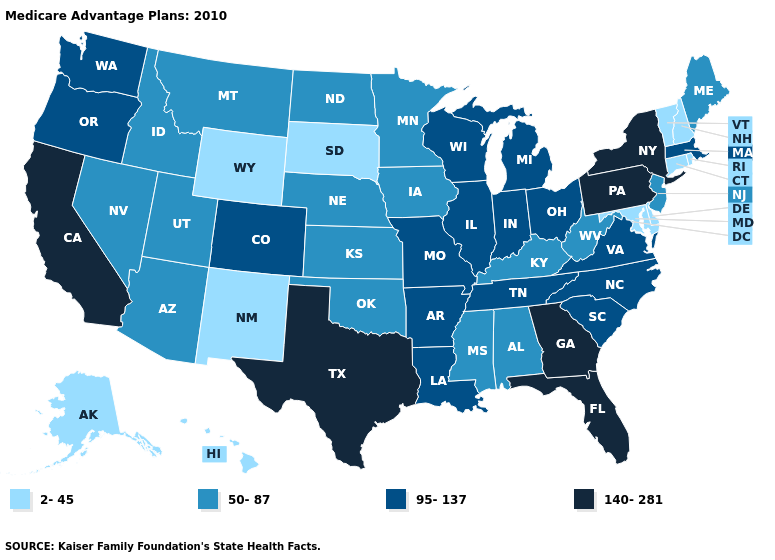Name the states that have a value in the range 95-137?
Keep it brief. Arkansas, Colorado, Illinois, Indiana, Louisiana, Massachusetts, Michigan, Missouri, North Carolina, Ohio, Oregon, South Carolina, Tennessee, Virginia, Washington, Wisconsin. Does Kentucky have the lowest value in the South?
Keep it brief. No. Name the states that have a value in the range 50-87?
Short answer required. Alabama, Arizona, Iowa, Idaho, Kansas, Kentucky, Maine, Minnesota, Mississippi, Montana, North Dakota, Nebraska, New Jersey, Nevada, Oklahoma, Utah, West Virginia. Which states hav the highest value in the West?
Give a very brief answer. California. What is the highest value in the Northeast ?
Answer briefly. 140-281. Name the states that have a value in the range 95-137?
Short answer required. Arkansas, Colorado, Illinois, Indiana, Louisiana, Massachusetts, Michigan, Missouri, North Carolina, Ohio, Oregon, South Carolina, Tennessee, Virginia, Washington, Wisconsin. Does Wyoming have the highest value in the USA?
Concise answer only. No. What is the value of Michigan?
Short answer required. 95-137. Does Kentucky have the highest value in the South?
Short answer required. No. What is the highest value in states that border New Mexico?
Answer briefly. 140-281. How many symbols are there in the legend?
Be succinct. 4. Does Vermont have the highest value in the Northeast?
Concise answer only. No. Does Wyoming have the lowest value in the USA?
Short answer required. Yes. Which states have the highest value in the USA?
Give a very brief answer. California, Florida, Georgia, New York, Pennsylvania, Texas. Name the states that have a value in the range 2-45?
Keep it brief. Alaska, Connecticut, Delaware, Hawaii, Maryland, New Hampshire, New Mexico, Rhode Island, South Dakota, Vermont, Wyoming. 